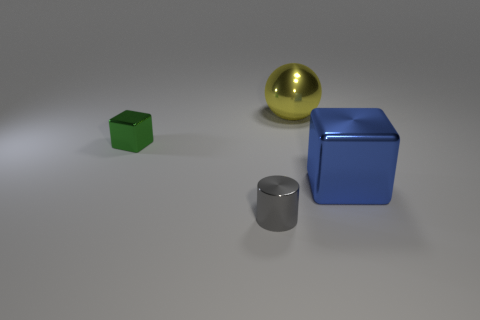Is there anything else that has the same shape as the green thing?
Keep it short and to the point. Yes. There is a cube that is on the left side of the large object that is right of the large metallic thing that is behind the green cube; what is its color?
Provide a succinct answer. Green. Are there fewer large yellow things in front of the gray thing than large blue blocks in front of the big blue cube?
Offer a terse response. No. Is the large blue object the same shape as the small green metallic thing?
Make the answer very short. Yes. What number of green blocks are the same size as the green thing?
Offer a terse response. 0. Is the number of big cubes that are in front of the large cube less than the number of big green cubes?
Make the answer very short. No. How big is the metallic object in front of the block that is on the right side of the gray thing?
Provide a succinct answer. Small. What number of objects are either tiny cyan metal blocks or small green things?
Make the answer very short. 1. Are there fewer big yellow things than tiny yellow metal cylinders?
Your answer should be very brief. No. How many things are either tiny shiny things or shiny cubes that are behind the blue metallic cube?
Your answer should be very brief. 2. 